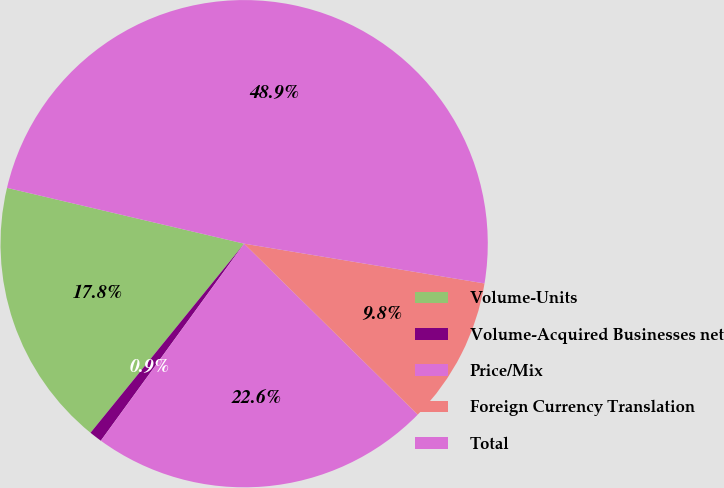Convert chart. <chart><loc_0><loc_0><loc_500><loc_500><pie_chart><fcel>Volume-Units<fcel>Volume-Acquired Businesses net<fcel>Price/Mix<fcel>Foreign Currency Translation<fcel>Total<nl><fcel>17.82%<fcel>0.85%<fcel>22.63%<fcel>9.77%<fcel>48.93%<nl></chart> 